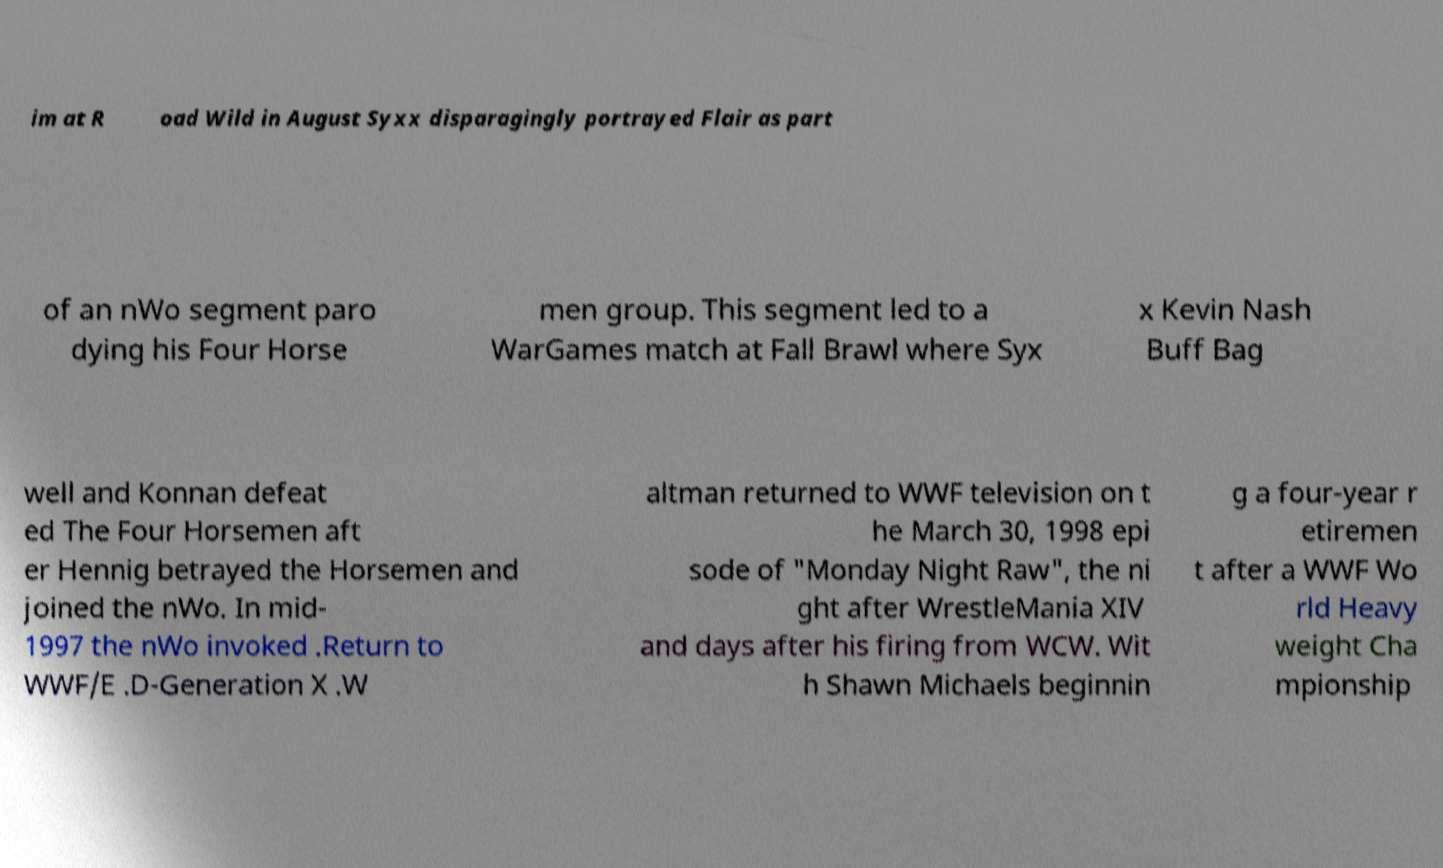What messages or text are displayed in this image? I need them in a readable, typed format. im at R oad Wild in August Syxx disparagingly portrayed Flair as part of an nWo segment paro dying his Four Horse men group. This segment led to a WarGames match at Fall Brawl where Syx x Kevin Nash Buff Bag well and Konnan defeat ed The Four Horsemen aft er Hennig betrayed the Horsemen and joined the nWo. In mid- 1997 the nWo invoked .Return to WWF/E .D-Generation X .W altman returned to WWF television on t he March 30, 1998 epi sode of "Monday Night Raw", the ni ght after WrestleMania XIV and days after his firing from WCW. Wit h Shawn Michaels beginnin g a four-year r etiremen t after a WWF Wo rld Heavy weight Cha mpionship 